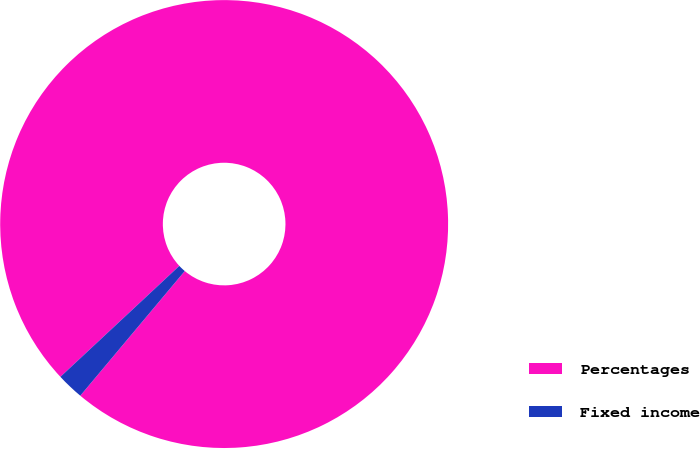<chart> <loc_0><loc_0><loc_500><loc_500><pie_chart><fcel>Percentages<fcel>Fixed income<nl><fcel>98.05%<fcel>1.95%<nl></chart> 